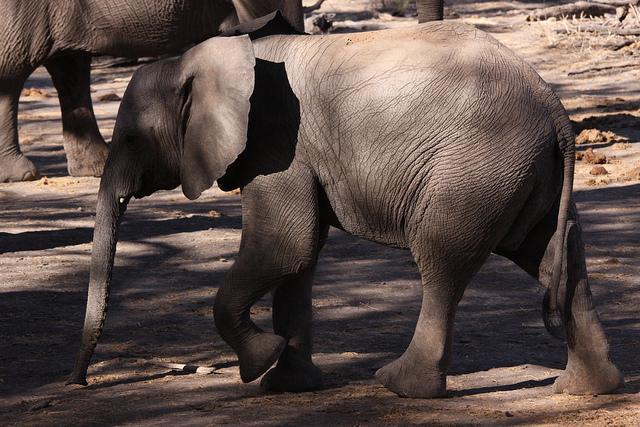How many elephants can you see?
Give a very brief answer. 2. How many chairs are depicted?
Give a very brief answer. 0. 